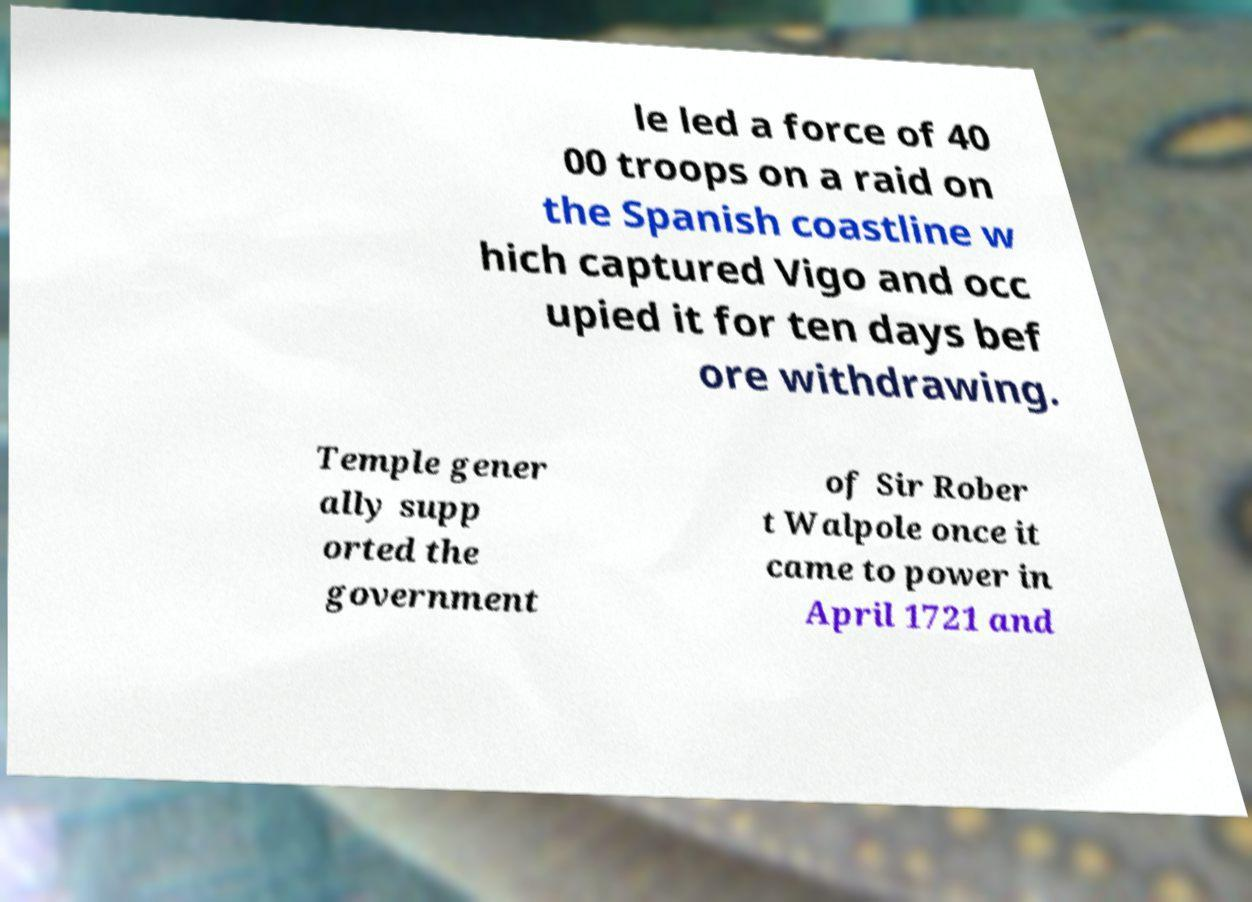I need the written content from this picture converted into text. Can you do that? le led a force of 40 00 troops on a raid on the Spanish coastline w hich captured Vigo and occ upied it for ten days bef ore withdrawing. Temple gener ally supp orted the government of Sir Rober t Walpole once it came to power in April 1721 and 